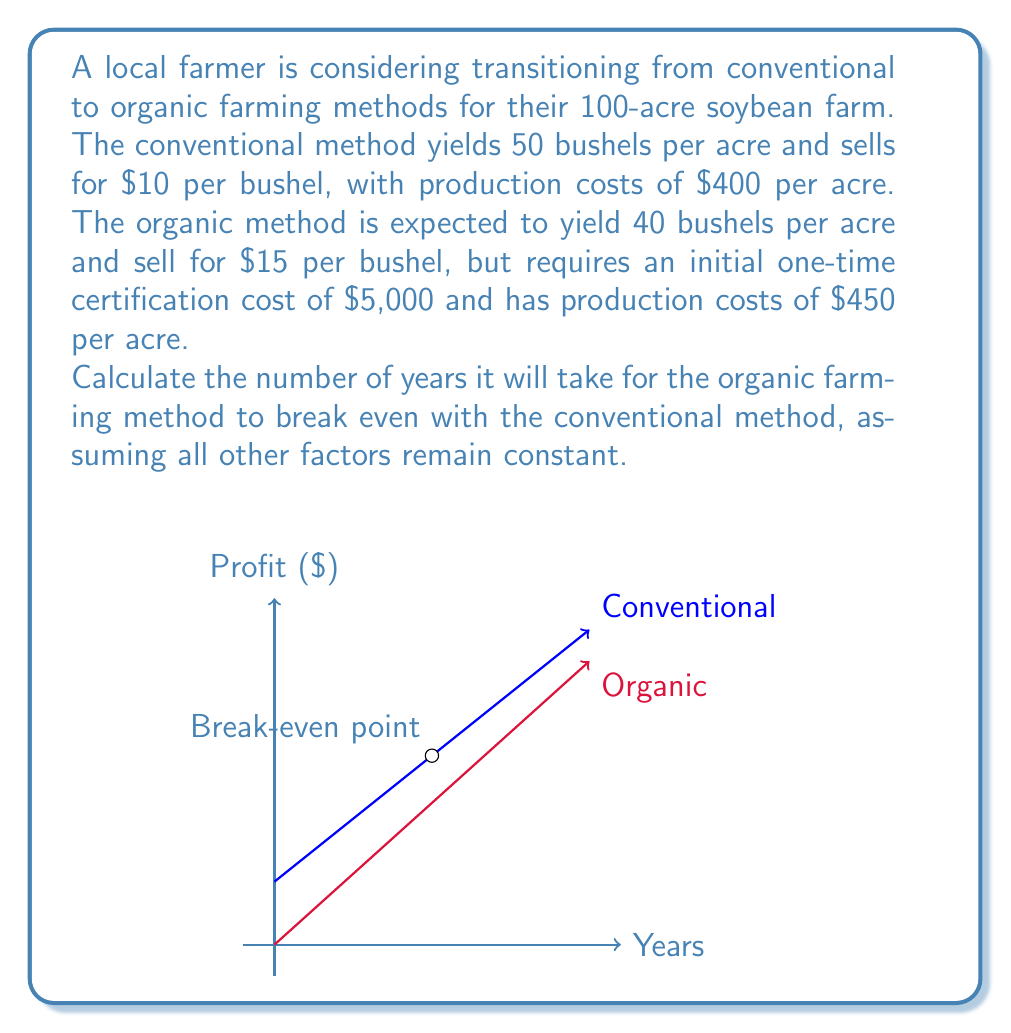Help me with this question. Let's approach this step-by-step:

1) First, calculate the annual profit for conventional farming:
   Revenue = 100 acres × 50 bushels/acre × $10/bushel = $50,000
   Costs = 100 acres × $400/acre = $40,000
   Annual Profit (Conventional) = $50,000 - $40,000 = $10,000

2) Now, calculate the annual profit for organic farming:
   Revenue = 100 acres × 40 bushels/acre × $15/bushel = $60,000
   Costs = 100 acres × $450/acre = $45,000
   Annual Profit (Organic) = $60,000 - $45,000 = $15,000

3) The difference in annual profit is:
   $15,000 - $10,000 = $5,000 in favor of organic farming

4) However, there's an initial certification cost of $5,000 for organic farming.

5) To find the break-even point, we need to determine when the cumulative profit difference equals the certification cost:

   Let $x$ be the number of years. We can set up the equation:
   $$5000x = 5000$$

6) Solving for $x$:
   $$x = \frac{5000}{5000} = 1$$

Therefore, it will take 1 year for the organic method to break even with the conventional method.
Answer: 1 year 